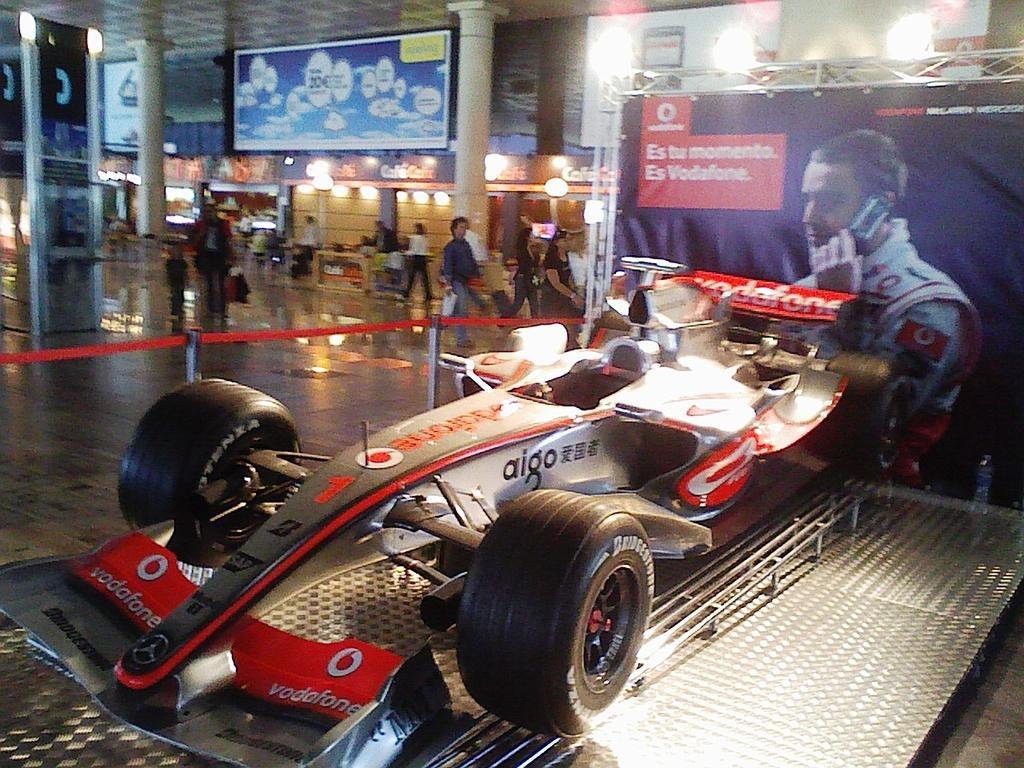Could you give a brief overview of what you see in this image? In this picture we can see banner truss, boards, lights, pillars, floor, people, barrier poles and objects. On the right side of the picture we can see a vehicle on a platform. 